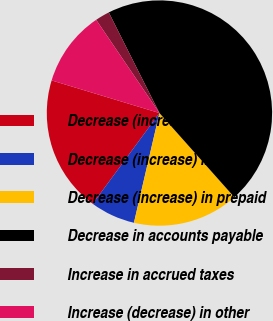Convert chart to OTSL. <chart><loc_0><loc_0><loc_500><loc_500><pie_chart><fcel>Decrease (increase) in trade<fcel>Decrease (increase) in<fcel>Decrease (increase) in prepaid<fcel>Decrease in accounts payable<fcel>Increase in accrued taxes<fcel>Increase (decrease) in other<nl><fcel>19.59%<fcel>6.45%<fcel>15.21%<fcel>45.85%<fcel>2.07%<fcel>10.83%<nl></chart> 